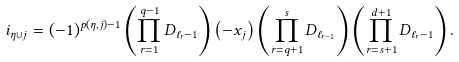<formula> <loc_0><loc_0><loc_500><loc_500>i _ { \eta \cup j } = ( - 1 ) ^ { p ( \eta , j ) - 1 } \left ( \prod _ { r = 1 } ^ { q - 1 } { D _ { { \ell _ { r } } - 1 } } \right ) \left ( - x _ { j } \right ) \left ( \prod _ { r = q + 1 } ^ { s } { D _ { \ell _ { r - 1 } } } \right ) \left ( \prod _ { r = s + 1 } ^ { d + 1 } { D _ { \ell _ { r } - 1 } } \right ) .</formula> 